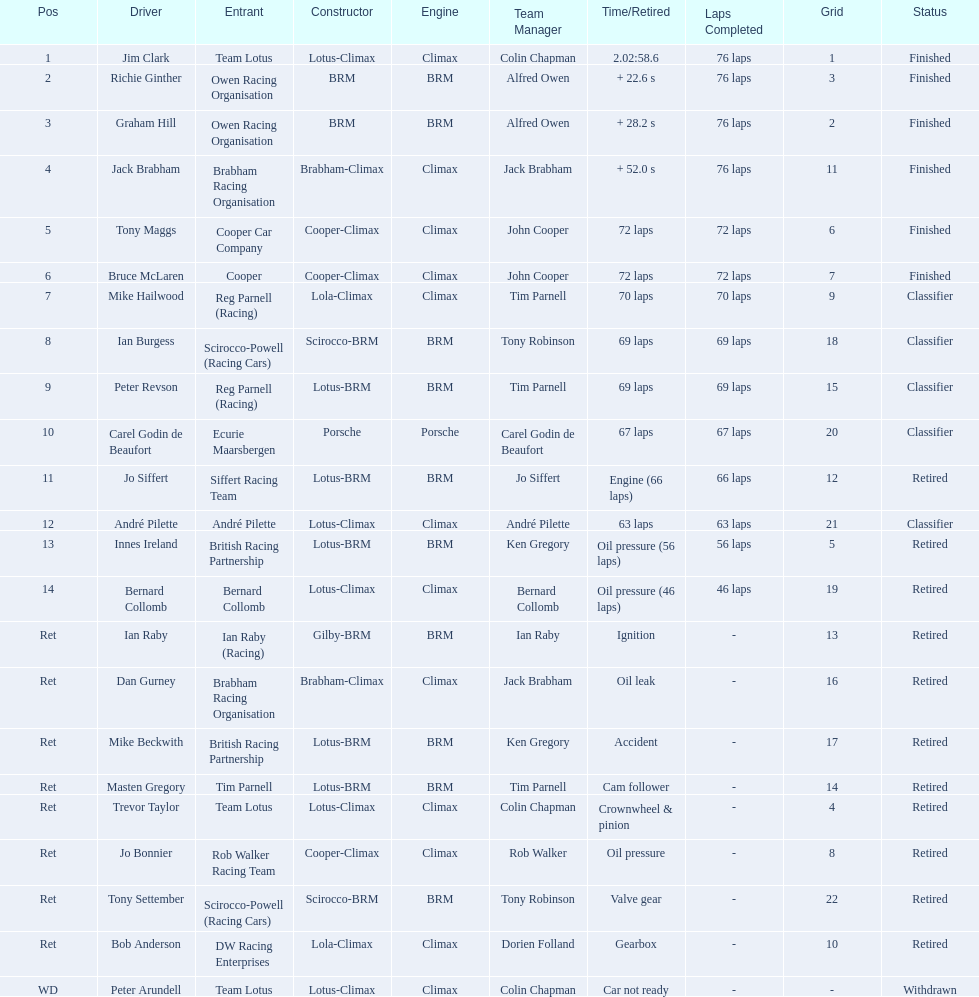Who drove in the 1963 international gold cup? Jim Clark, Richie Ginther, Graham Hill, Jack Brabham, Tony Maggs, Bruce McLaren, Mike Hailwood, Ian Burgess, Peter Revson, Carel Godin de Beaufort, Jo Siffert, André Pilette, Innes Ireland, Bernard Collomb, Ian Raby, Dan Gurney, Mike Beckwith, Masten Gregory, Trevor Taylor, Jo Bonnier, Tony Settember, Bob Anderson, Peter Arundell. Who had problems during the race? Jo Siffert, Innes Ireland, Bernard Collomb, Ian Raby, Dan Gurney, Mike Beckwith, Masten Gregory, Trevor Taylor, Jo Bonnier, Tony Settember, Bob Anderson, Peter Arundell. Of those who was still able to finish the race? Jo Siffert, Innes Ireland, Bernard Collomb. Of those who faced the same issue? Innes Ireland, Bernard Collomb. What issue did they have? Oil pressure. 